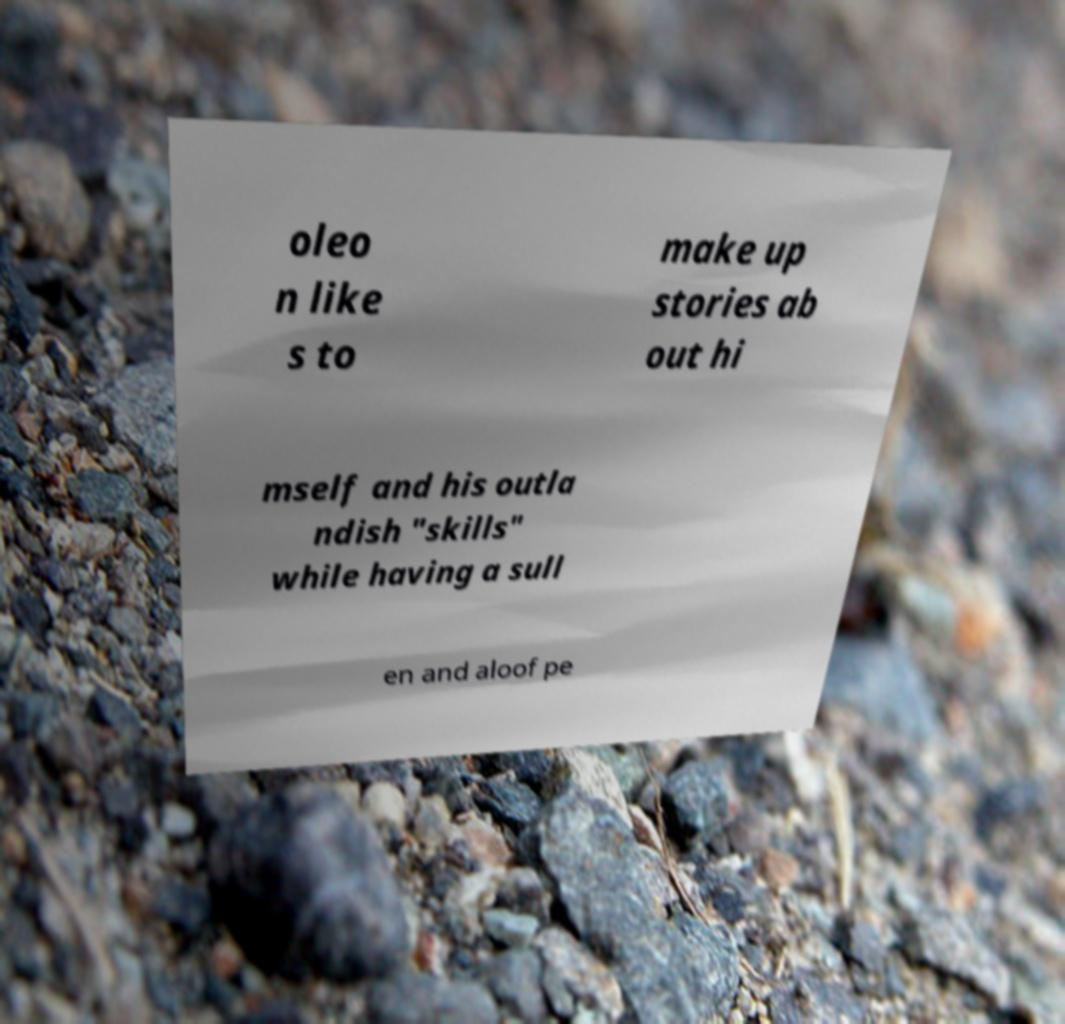Can you read and provide the text displayed in the image?This photo seems to have some interesting text. Can you extract and type it out for me? oleo n like s to make up stories ab out hi mself and his outla ndish "skills" while having a sull en and aloof pe 